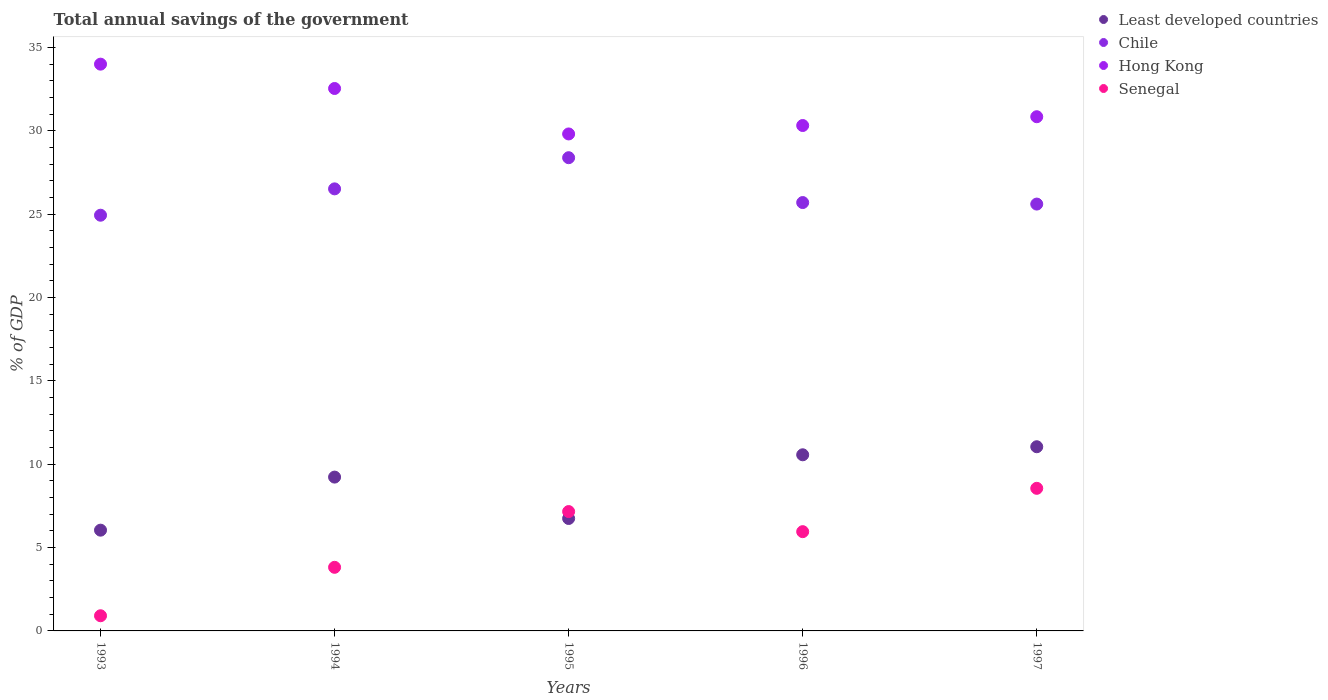How many different coloured dotlines are there?
Your answer should be compact. 4. Is the number of dotlines equal to the number of legend labels?
Offer a terse response. Yes. What is the total annual savings of the government in Chile in 1995?
Your answer should be very brief. 28.38. Across all years, what is the maximum total annual savings of the government in Least developed countries?
Provide a succinct answer. 11.05. Across all years, what is the minimum total annual savings of the government in Chile?
Keep it short and to the point. 24.94. In which year was the total annual savings of the government in Hong Kong maximum?
Your answer should be very brief. 1993. What is the total total annual savings of the government in Chile in the graph?
Ensure brevity in your answer.  131.13. What is the difference between the total annual savings of the government in Chile in 1996 and that in 1997?
Offer a very short reply. 0.09. What is the difference between the total annual savings of the government in Chile in 1994 and the total annual savings of the government in Least developed countries in 1996?
Provide a succinct answer. 15.95. What is the average total annual savings of the government in Chile per year?
Ensure brevity in your answer.  26.23. In the year 1993, what is the difference between the total annual savings of the government in Least developed countries and total annual savings of the government in Senegal?
Ensure brevity in your answer.  5.13. In how many years, is the total annual savings of the government in Chile greater than 9 %?
Your answer should be compact. 5. What is the ratio of the total annual savings of the government in Hong Kong in 1995 to that in 1997?
Your answer should be compact. 0.97. Is the total annual savings of the government in Senegal in 1993 less than that in 1994?
Ensure brevity in your answer.  Yes. Is the difference between the total annual savings of the government in Least developed countries in 1995 and 1996 greater than the difference between the total annual savings of the government in Senegal in 1995 and 1996?
Give a very brief answer. No. What is the difference between the highest and the second highest total annual savings of the government in Senegal?
Ensure brevity in your answer.  1.39. What is the difference between the highest and the lowest total annual savings of the government in Hong Kong?
Give a very brief answer. 4.19. Is it the case that in every year, the sum of the total annual savings of the government in Least developed countries and total annual savings of the government in Chile  is greater than the total annual savings of the government in Hong Kong?
Provide a short and direct response. No. Does the total annual savings of the government in Hong Kong monotonically increase over the years?
Make the answer very short. No. Is the total annual savings of the government in Chile strictly less than the total annual savings of the government in Least developed countries over the years?
Give a very brief answer. No. How many years are there in the graph?
Offer a terse response. 5. What is the title of the graph?
Provide a succinct answer. Total annual savings of the government. What is the label or title of the X-axis?
Your answer should be compact. Years. What is the label or title of the Y-axis?
Your response must be concise. % of GDP. What is the % of GDP of Least developed countries in 1993?
Make the answer very short. 6.04. What is the % of GDP of Chile in 1993?
Offer a terse response. 24.94. What is the % of GDP in Hong Kong in 1993?
Offer a very short reply. 34. What is the % of GDP of Senegal in 1993?
Offer a terse response. 0.91. What is the % of GDP of Least developed countries in 1994?
Provide a short and direct response. 9.23. What is the % of GDP of Chile in 1994?
Your answer should be very brief. 26.52. What is the % of GDP of Hong Kong in 1994?
Your answer should be compact. 32.54. What is the % of GDP in Senegal in 1994?
Your answer should be compact. 3.82. What is the % of GDP of Least developed countries in 1995?
Your answer should be very brief. 6.74. What is the % of GDP in Chile in 1995?
Offer a terse response. 28.38. What is the % of GDP in Hong Kong in 1995?
Your answer should be very brief. 29.81. What is the % of GDP in Senegal in 1995?
Make the answer very short. 7.16. What is the % of GDP in Least developed countries in 1996?
Make the answer very short. 10.56. What is the % of GDP in Chile in 1996?
Keep it short and to the point. 25.69. What is the % of GDP in Hong Kong in 1996?
Your answer should be very brief. 30.32. What is the % of GDP of Senegal in 1996?
Your response must be concise. 5.95. What is the % of GDP of Least developed countries in 1997?
Your response must be concise. 11.05. What is the % of GDP in Chile in 1997?
Offer a terse response. 25.6. What is the % of GDP in Hong Kong in 1997?
Your response must be concise. 30.84. What is the % of GDP in Senegal in 1997?
Ensure brevity in your answer.  8.55. Across all years, what is the maximum % of GDP of Least developed countries?
Offer a very short reply. 11.05. Across all years, what is the maximum % of GDP of Chile?
Ensure brevity in your answer.  28.38. Across all years, what is the maximum % of GDP of Hong Kong?
Give a very brief answer. 34. Across all years, what is the maximum % of GDP in Senegal?
Your answer should be very brief. 8.55. Across all years, what is the minimum % of GDP in Least developed countries?
Ensure brevity in your answer.  6.04. Across all years, what is the minimum % of GDP in Chile?
Offer a very short reply. 24.94. Across all years, what is the minimum % of GDP of Hong Kong?
Your answer should be very brief. 29.81. Across all years, what is the minimum % of GDP in Senegal?
Your answer should be very brief. 0.91. What is the total % of GDP in Least developed countries in the graph?
Offer a very short reply. 43.63. What is the total % of GDP in Chile in the graph?
Your response must be concise. 131.13. What is the total % of GDP of Hong Kong in the graph?
Offer a terse response. 157.5. What is the total % of GDP of Senegal in the graph?
Your answer should be compact. 26.39. What is the difference between the % of GDP of Least developed countries in 1993 and that in 1994?
Provide a succinct answer. -3.18. What is the difference between the % of GDP of Chile in 1993 and that in 1994?
Offer a terse response. -1.58. What is the difference between the % of GDP in Hong Kong in 1993 and that in 1994?
Keep it short and to the point. 1.46. What is the difference between the % of GDP in Senegal in 1993 and that in 1994?
Provide a short and direct response. -2.91. What is the difference between the % of GDP of Least developed countries in 1993 and that in 1995?
Your response must be concise. -0.7. What is the difference between the % of GDP of Chile in 1993 and that in 1995?
Make the answer very short. -3.45. What is the difference between the % of GDP of Hong Kong in 1993 and that in 1995?
Offer a very short reply. 4.19. What is the difference between the % of GDP in Senegal in 1993 and that in 1995?
Make the answer very short. -6.25. What is the difference between the % of GDP of Least developed countries in 1993 and that in 1996?
Ensure brevity in your answer.  -4.52. What is the difference between the % of GDP in Chile in 1993 and that in 1996?
Your answer should be very brief. -0.76. What is the difference between the % of GDP of Hong Kong in 1993 and that in 1996?
Your answer should be compact. 3.68. What is the difference between the % of GDP in Senegal in 1993 and that in 1996?
Give a very brief answer. -5.04. What is the difference between the % of GDP of Least developed countries in 1993 and that in 1997?
Your answer should be compact. -5. What is the difference between the % of GDP in Chile in 1993 and that in 1997?
Your answer should be compact. -0.67. What is the difference between the % of GDP in Hong Kong in 1993 and that in 1997?
Offer a very short reply. 3.15. What is the difference between the % of GDP in Senegal in 1993 and that in 1997?
Your answer should be compact. -7.64. What is the difference between the % of GDP in Least developed countries in 1994 and that in 1995?
Offer a very short reply. 2.48. What is the difference between the % of GDP of Chile in 1994 and that in 1995?
Your response must be concise. -1.87. What is the difference between the % of GDP of Hong Kong in 1994 and that in 1995?
Provide a short and direct response. 2.73. What is the difference between the % of GDP in Senegal in 1994 and that in 1995?
Give a very brief answer. -3.34. What is the difference between the % of GDP of Least developed countries in 1994 and that in 1996?
Provide a succinct answer. -1.34. What is the difference between the % of GDP in Chile in 1994 and that in 1996?
Keep it short and to the point. 0.82. What is the difference between the % of GDP of Hong Kong in 1994 and that in 1996?
Provide a succinct answer. 2.22. What is the difference between the % of GDP in Senegal in 1994 and that in 1996?
Your response must be concise. -2.14. What is the difference between the % of GDP in Least developed countries in 1994 and that in 1997?
Your response must be concise. -1.82. What is the difference between the % of GDP of Chile in 1994 and that in 1997?
Your response must be concise. 0.91. What is the difference between the % of GDP in Hong Kong in 1994 and that in 1997?
Make the answer very short. 1.69. What is the difference between the % of GDP of Senegal in 1994 and that in 1997?
Keep it short and to the point. -4.74. What is the difference between the % of GDP of Least developed countries in 1995 and that in 1996?
Make the answer very short. -3.82. What is the difference between the % of GDP of Chile in 1995 and that in 1996?
Your response must be concise. 2.69. What is the difference between the % of GDP in Hong Kong in 1995 and that in 1996?
Give a very brief answer. -0.51. What is the difference between the % of GDP in Senegal in 1995 and that in 1996?
Keep it short and to the point. 1.21. What is the difference between the % of GDP in Least developed countries in 1995 and that in 1997?
Your response must be concise. -4.3. What is the difference between the % of GDP of Chile in 1995 and that in 1997?
Offer a terse response. 2.78. What is the difference between the % of GDP of Hong Kong in 1995 and that in 1997?
Your answer should be very brief. -1.03. What is the difference between the % of GDP of Senegal in 1995 and that in 1997?
Your response must be concise. -1.39. What is the difference between the % of GDP of Least developed countries in 1996 and that in 1997?
Offer a very short reply. -0.48. What is the difference between the % of GDP of Chile in 1996 and that in 1997?
Offer a very short reply. 0.09. What is the difference between the % of GDP in Hong Kong in 1996 and that in 1997?
Provide a succinct answer. -0.53. What is the difference between the % of GDP of Senegal in 1996 and that in 1997?
Provide a succinct answer. -2.6. What is the difference between the % of GDP in Least developed countries in 1993 and the % of GDP in Chile in 1994?
Keep it short and to the point. -20.47. What is the difference between the % of GDP in Least developed countries in 1993 and the % of GDP in Hong Kong in 1994?
Provide a short and direct response. -26.49. What is the difference between the % of GDP of Least developed countries in 1993 and the % of GDP of Senegal in 1994?
Your response must be concise. 2.23. What is the difference between the % of GDP of Chile in 1993 and the % of GDP of Hong Kong in 1994?
Your response must be concise. -7.6. What is the difference between the % of GDP of Chile in 1993 and the % of GDP of Senegal in 1994?
Ensure brevity in your answer.  21.12. What is the difference between the % of GDP of Hong Kong in 1993 and the % of GDP of Senegal in 1994?
Offer a very short reply. 30.18. What is the difference between the % of GDP in Least developed countries in 1993 and the % of GDP in Chile in 1995?
Keep it short and to the point. -22.34. What is the difference between the % of GDP of Least developed countries in 1993 and the % of GDP of Hong Kong in 1995?
Make the answer very short. -23.77. What is the difference between the % of GDP in Least developed countries in 1993 and the % of GDP in Senegal in 1995?
Ensure brevity in your answer.  -1.12. What is the difference between the % of GDP of Chile in 1993 and the % of GDP of Hong Kong in 1995?
Your answer should be very brief. -4.87. What is the difference between the % of GDP in Chile in 1993 and the % of GDP in Senegal in 1995?
Give a very brief answer. 17.78. What is the difference between the % of GDP of Hong Kong in 1993 and the % of GDP of Senegal in 1995?
Ensure brevity in your answer.  26.84. What is the difference between the % of GDP in Least developed countries in 1993 and the % of GDP in Chile in 1996?
Give a very brief answer. -19.65. What is the difference between the % of GDP in Least developed countries in 1993 and the % of GDP in Hong Kong in 1996?
Ensure brevity in your answer.  -24.27. What is the difference between the % of GDP in Least developed countries in 1993 and the % of GDP in Senegal in 1996?
Offer a very short reply. 0.09. What is the difference between the % of GDP in Chile in 1993 and the % of GDP in Hong Kong in 1996?
Your response must be concise. -5.38. What is the difference between the % of GDP in Chile in 1993 and the % of GDP in Senegal in 1996?
Give a very brief answer. 18.98. What is the difference between the % of GDP in Hong Kong in 1993 and the % of GDP in Senegal in 1996?
Keep it short and to the point. 28.04. What is the difference between the % of GDP of Least developed countries in 1993 and the % of GDP of Chile in 1997?
Your response must be concise. -19.56. What is the difference between the % of GDP in Least developed countries in 1993 and the % of GDP in Hong Kong in 1997?
Offer a very short reply. -24.8. What is the difference between the % of GDP in Least developed countries in 1993 and the % of GDP in Senegal in 1997?
Ensure brevity in your answer.  -2.51. What is the difference between the % of GDP of Chile in 1993 and the % of GDP of Hong Kong in 1997?
Your answer should be compact. -5.91. What is the difference between the % of GDP in Chile in 1993 and the % of GDP in Senegal in 1997?
Ensure brevity in your answer.  16.38. What is the difference between the % of GDP of Hong Kong in 1993 and the % of GDP of Senegal in 1997?
Give a very brief answer. 25.44. What is the difference between the % of GDP in Least developed countries in 1994 and the % of GDP in Chile in 1995?
Make the answer very short. -19.16. What is the difference between the % of GDP in Least developed countries in 1994 and the % of GDP in Hong Kong in 1995?
Your answer should be compact. -20.58. What is the difference between the % of GDP in Least developed countries in 1994 and the % of GDP in Senegal in 1995?
Provide a short and direct response. 2.07. What is the difference between the % of GDP in Chile in 1994 and the % of GDP in Hong Kong in 1995?
Offer a very short reply. -3.29. What is the difference between the % of GDP in Chile in 1994 and the % of GDP in Senegal in 1995?
Provide a succinct answer. 19.36. What is the difference between the % of GDP in Hong Kong in 1994 and the % of GDP in Senegal in 1995?
Your answer should be compact. 25.38. What is the difference between the % of GDP in Least developed countries in 1994 and the % of GDP in Chile in 1996?
Ensure brevity in your answer.  -16.47. What is the difference between the % of GDP in Least developed countries in 1994 and the % of GDP in Hong Kong in 1996?
Give a very brief answer. -21.09. What is the difference between the % of GDP of Least developed countries in 1994 and the % of GDP of Senegal in 1996?
Your response must be concise. 3.27. What is the difference between the % of GDP in Chile in 1994 and the % of GDP in Hong Kong in 1996?
Make the answer very short. -3.8. What is the difference between the % of GDP of Chile in 1994 and the % of GDP of Senegal in 1996?
Your answer should be compact. 20.56. What is the difference between the % of GDP in Hong Kong in 1994 and the % of GDP in Senegal in 1996?
Offer a very short reply. 26.58. What is the difference between the % of GDP in Least developed countries in 1994 and the % of GDP in Chile in 1997?
Offer a very short reply. -16.38. What is the difference between the % of GDP in Least developed countries in 1994 and the % of GDP in Hong Kong in 1997?
Your answer should be compact. -21.62. What is the difference between the % of GDP of Least developed countries in 1994 and the % of GDP of Senegal in 1997?
Keep it short and to the point. 0.67. What is the difference between the % of GDP in Chile in 1994 and the % of GDP in Hong Kong in 1997?
Offer a very short reply. -4.33. What is the difference between the % of GDP of Chile in 1994 and the % of GDP of Senegal in 1997?
Provide a short and direct response. 17.96. What is the difference between the % of GDP of Hong Kong in 1994 and the % of GDP of Senegal in 1997?
Make the answer very short. 23.98. What is the difference between the % of GDP in Least developed countries in 1995 and the % of GDP in Chile in 1996?
Your response must be concise. -18.95. What is the difference between the % of GDP in Least developed countries in 1995 and the % of GDP in Hong Kong in 1996?
Offer a terse response. -23.57. What is the difference between the % of GDP of Least developed countries in 1995 and the % of GDP of Senegal in 1996?
Your response must be concise. 0.79. What is the difference between the % of GDP of Chile in 1995 and the % of GDP of Hong Kong in 1996?
Offer a terse response. -1.93. What is the difference between the % of GDP in Chile in 1995 and the % of GDP in Senegal in 1996?
Ensure brevity in your answer.  22.43. What is the difference between the % of GDP of Hong Kong in 1995 and the % of GDP of Senegal in 1996?
Keep it short and to the point. 23.86. What is the difference between the % of GDP in Least developed countries in 1995 and the % of GDP in Chile in 1997?
Your answer should be compact. -18.86. What is the difference between the % of GDP in Least developed countries in 1995 and the % of GDP in Hong Kong in 1997?
Make the answer very short. -24.1. What is the difference between the % of GDP of Least developed countries in 1995 and the % of GDP of Senegal in 1997?
Your answer should be compact. -1.81. What is the difference between the % of GDP of Chile in 1995 and the % of GDP of Hong Kong in 1997?
Provide a short and direct response. -2.46. What is the difference between the % of GDP in Chile in 1995 and the % of GDP in Senegal in 1997?
Provide a short and direct response. 19.83. What is the difference between the % of GDP in Hong Kong in 1995 and the % of GDP in Senegal in 1997?
Your response must be concise. 21.26. What is the difference between the % of GDP in Least developed countries in 1996 and the % of GDP in Chile in 1997?
Make the answer very short. -15.04. What is the difference between the % of GDP of Least developed countries in 1996 and the % of GDP of Hong Kong in 1997?
Ensure brevity in your answer.  -20.28. What is the difference between the % of GDP of Least developed countries in 1996 and the % of GDP of Senegal in 1997?
Offer a terse response. 2.01. What is the difference between the % of GDP of Chile in 1996 and the % of GDP of Hong Kong in 1997?
Keep it short and to the point. -5.15. What is the difference between the % of GDP of Chile in 1996 and the % of GDP of Senegal in 1997?
Make the answer very short. 17.14. What is the difference between the % of GDP of Hong Kong in 1996 and the % of GDP of Senegal in 1997?
Your response must be concise. 21.76. What is the average % of GDP in Least developed countries per year?
Your response must be concise. 8.73. What is the average % of GDP of Chile per year?
Keep it short and to the point. 26.23. What is the average % of GDP of Hong Kong per year?
Keep it short and to the point. 31.5. What is the average % of GDP of Senegal per year?
Provide a succinct answer. 5.28. In the year 1993, what is the difference between the % of GDP in Least developed countries and % of GDP in Chile?
Ensure brevity in your answer.  -18.89. In the year 1993, what is the difference between the % of GDP in Least developed countries and % of GDP in Hong Kong?
Your answer should be very brief. -27.95. In the year 1993, what is the difference between the % of GDP of Least developed countries and % of GDP of Senegal?
Your answer should be very brief. 5.13. In the year 1993, what is the difference between the % of GDP of Chile and % of GDP of Hong Kong?
Offer a very short reply. -9.06. In the year 1993, what is the difference between the % of GDP in Chile and % of GDP in Senegal?
Give a very brief answer. 24.03. In the year 1993, what is the difference between the % of GDP of Hong Kong and % of GDP of Senegal?
Ensure brevity in your answer.  33.09. In the year 1994, what is the difference between the % of GDP in Least developed countries and % of GDP in Chile?
Ensure brevity in your answer.  -17.29. In the year 1994, what is the difference between the % of GDP in Least developed countries and % of GDP in Hong Kong?
Your answer should be very brief. -23.31. In the year 1994, what is the difference between the % of GDP in Least developed countries and % of GDP in Senegal?
Offer a terse response. 5.41. In the year 1994, what is the difference between the % of GDP in Chile and % of GDP in Hong Kong?
Offer a very short reply. -6.02. In the year 1994, what is the difference between the % of GDP in Chile and % of GDP in Senegal?
Provide a succinct answer. 22.7. In the year 1994, what is the difference between the % of GDP in Hong Kong and % of GDP in Senegal?
Offer a terse response. 28.72. In the year 1995, what is the difference between the % of GDP in Least developed countries and % of GDP in Chile?
Your answer should be compact. -21.64. In the year 1995, what is the difference between the % of GDP in Least developed countries and % of GDP in Hong Kong?
Give a very brief answer. -23.07. In the year 1995, what is the difference between the % of GDP in Least developed countries and % of GDP in Senegal?
Offer a very short reply. -0.42. In the year 1995, what is the difference between the % of GDP of Chile and % of GDP of Hong Kong?
Ensure brevity in your answer.  -1.42. In the year 1995, what is the difference between the % of GDP in Chile and % of GDP in Senegal?
Ensure brevity in your answer.  21.23. In the year 1995, what is the difference between the % of GDP in Hong Kong and % of GDP in Senegal?
Provide a succinct answer. 22.65. In the year 1996, what is the difference between the % of GDP in Least developed countries and % of GDP in Chile?
Provide a succinct answer. -15.13. In the year 1996, what is the difference between the % of GDP in Least developed countries and % of GDP in Hong Kong?
Make the answer very short. -19.75. In the year 1996, what is the difference between the % of GDP of Least developed countries and % of GDP of Senegal?
Your response must be concise. 4.61. In the year 1996, what is the difference between the % of GDP in Chile and % of GDP in Hong Kong?
Your answer should be very brief. -4.62. In the year 1996, what is the difference between the % of GDP in Chile and % of GDP in Senegal?
Your answer should be very brief. 19.74. In the year 1996, what is the difference between the % of GDP of Hong Kong and % of GDP of Senegal?
Give a very brief answer. 24.36. In the year 1997, what is the difference between the % of GDP in Least developed countries and % of GDP in Chile?
Your answer should be compact. -14.56. In the year 1997, what is the difference between the % of GDP of Least developed countries and % of GDP of Hong Kong?
Your answer should be very brief. -19.79. In the year 1997, what is the difference between the % of GDP of Least developed countries and % of GDP of Senegal?
Provide a short and direct response. 2.49. In the year 1997, what is the difference between the % of GDP of Chile and % of GDP of Hong Kong?
Provide a succinct answer. -5.24. In the year 1997, what is the difference between the % of GDP of Chile and % of GDP of Senegal?
Your response must be concise. 17.05. In the year 1997, what is the difference between the % of GDP of Hong Kong and % of GDP of Senegal?
Your answer should be very brief. 22.29. What is the ratio of the % of GDP of Least developed countries in 1993 to that in 1994?
Provide a short and direct response. 0.66. What is the ratio of the % of GDP of Chile in 1993 to that in 1994?
Offer a terse response. 0.94. What is the ratio of the % of GDP in Hong Kong in 1993 to that in 1994?
Your answer should be very brief. 1.04. What is the ratio of the % of GDP of Senegal in 1993 to that in 1994?
Offer a very short reply. 0.24. What is the ratio of the % of GDP of Least developed countries in 1993 to that in 1995?
Offer a terse response. 0.9. What is the ratio of the % of GDP in Chile in 1993 to that in 1995?
Provide a short and direct response. 0.88. What is the ratio of the % of GDP of Hong Kong in 1993 to that in 1995?
Offer a terse response. 1.14. What is the ratio of the % of GDP in Senegal in 1993 to that in 1995?
Keep it short and to the point. 0.13. What is the ratio of the % of GDP of Least developed countries in 1993 to that in 1996?
Offer a very short reply. 0.57. What is the ratio of the % of GDP of Chile in 1993 to that in 1996?
Provide a succinct answer. 0.97. What is the ratio of the % of GDP of Hong Kong in 1993 to that in 1996?
Give a very brief answer. 1.12. What is the ratio of the % of GDP of Senegal in 1993 to that in 1996?
Ensure brevity in your answer.  0.15. What is the ratio of the % of GDP in Least developed countries in 1993 to that in 1997?
Make the answer very short. 0.55. What is the ratio of the % of GDP in Chile in 1993 to that in 1997?
Offer a terse response. 0.97. What is the ratio of the % of GDP of Hong Kong in 1993 to that in 1997?
Keep it short and to the point. 1.1. What is the ratio of the % of GDP of Senegal in 1993 to that in 1997?
Offer a terse response. 0.11. What is the ratio of the % of GDP in Least developed countries in 1994 to that in 1995?
Your answer should be compact. 1.37. What is the ratio of the % of GDP in Chile in 1994 to that in 1995?
Give a very brief answer. 0.93. What is the ratio of the % of GDP in Hong Kong in 1994 to that in 1995?
Your answer should be very brief. 1.09. What is the ratio of the % of GDP in Senegal in 1994 to that in 1995?
Make the answer very short. 0.53. What is the ratio of the % of GDP in Least developed countries in 1994 to that in 1996?
Your answer should be very brief. 0.87. What is the ratio of the % of GDP in Chile in 1994 to that in 1996?
Offer a very short reply. 1.03. What is the ratio of the % of GDP of Hong Kong in 1994 to that in 1996?
Provide a short and direct response. 1.07. What is the ratio of the % of GDP in Senegal in 1994 to that in 1996?
Your response must be concise. 0.64. What is the ratio of the % of GDP of Least developed countries in 1994 to that in 1997?
Keep it short and to the point. 0.84. What is the ratio of the % of GDP of Chile in 1994 to that in 1997?
Offer a terse response. 1.04. What is the ratio of the % of GDP in Hong Kong in 1994 to that in 1997?
Provide a short and direct response. 1.05. What is the ratio of the % of GDP of Senegal in 1994 to that in 1997?
Your answer should be compact. 0.45. What is the ratio of the % of GDP in Least developed countries in 1995 to that in 1996?
Offer a very short reply. 0.64. What is the ratio of the % of GDP in Chile in 1995 to that in 1996?
Your answer should be compact. 1.1. What is the ratio of the % of GDP of Hong Kong in 1995 to that in 1996?
Your answer should be very brief. 0.98. What is the ratio of the % of GDP in Senegal in 1995 to that in 1996?
Your answer should be compact. 1.2. What is the ratio of the % of GDP in Least developed countries in 1995 to that in 1997?
Provide a short and direct response. 0.61. What is the ratio of the % of GDP of Chile in 1995 to that in 1997?
Ensure brevity in your answer.  1.11. What is the ratio of the % of GDP in Hong Kong in 1995 to that in 1997?
Provide a short and direct response. 0.97. What is the ratio of the % of GDP in Senegal in 1995 to that in 1997?
Provide a succinct answer. 0.84. What is the ratio of the % of GDP of Least developed countries in 1996 to that in 1997?
Give a very brief answer. 0.96. What is the ratio of the % of GDP of Hong Kong in 1996 to that in 1997?
Offer a very short reply. 0.98. What is the ratio of the % of GDP of Senegal in 1996 to that in 1997?
Offer a terse response. 0.7. What is the difference between the highest and the second highest % of GDP of Least developed countries?
Offer a terse response. 0.48. What is the difference between the highest and the second highest % of GDP in Chile?
Offer a very short reply. 1.87. What is the difference between the highest and the second highest % of GDP in Hong Kong?
Provide a succinct answer. 1.46. What is the difference between the highest and the second highest % of GDP of Senegal?
Make the answer very short. 1.39. What is the difference between the highest and the lowest % of GDP of Least developed countries?
Keep it short and to the point. 5. What is the difference between the highest and the lowest % of GDP of Chile?
Provide a succinct answer. 3.45. What is the difference between the highest and the lowest % of GDP in Hong Kong?
Give a very brief answer. 4.19. What is the difference between the highest and the lowest % of GDP in Senegal?
Ensure brevity in your answer.  7.64. 